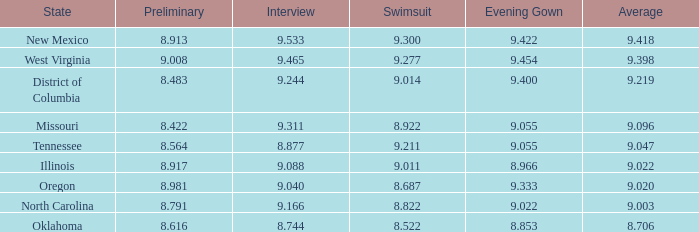Identify the initial stage for north carolina. 8.791. 